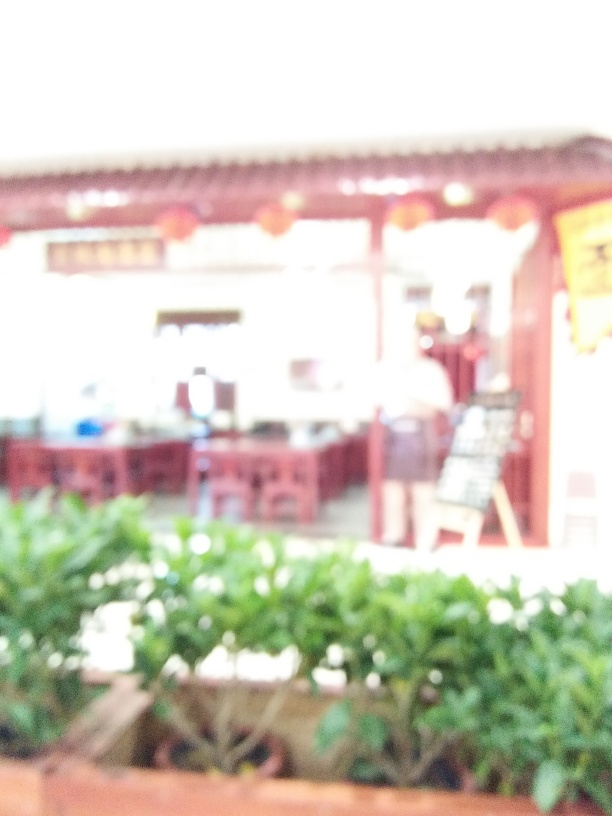Are there any people present in the photo? It's not easy to make out precise details due to the blurriness, but there appears to be a figure on the right side of the image, which suggests the presence of at least one person. 